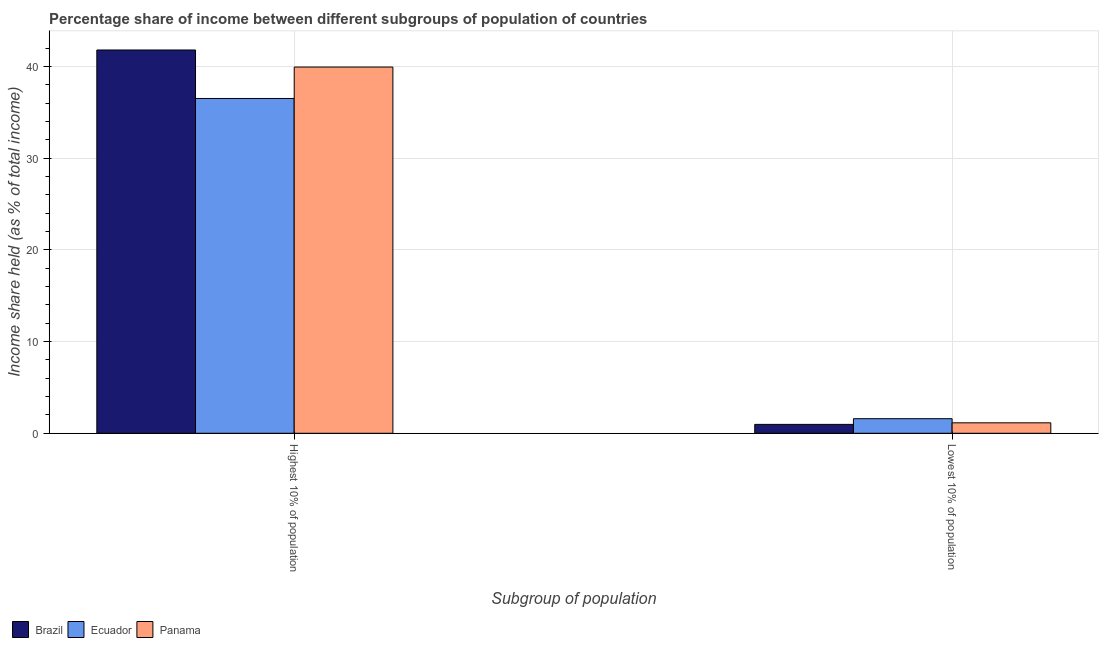How many different coloured bars are there?
Give a very brief answer. 3. How many groups of bars are there?
Your response must be concise. 2. What is the label of the 2nd group of bars from the left?
Your response must be concise. Lowest 10% of population. What is the income share held by highest 10% of the population in Ecuador?
Provide a short and direct response. 36.53. Across all countries, what is the maximum income share held by highest 10% of the population?
Offer a very short reply. 41.82. Across all countries, what is the minimum income share held by highest 10% of the population?
Offer a very short reply. 36.53. In which country was the income share held by highest 10% of the population maximum?
Offer a terse response. Brazil. In which country was the income share held by highest 10% of the population minimum?
Provide a short and direct response. Ecuador. What is the total income share held by highest 10% of the population in the graph?
Your response must be concise. 118.31. What is the difference between the income share held by highest 10% of the population in Brazil and that in Ecuador?
Provide a succinct answer. 5.29. What is the difference between the income share held by highest 10% of the population in Ecuador and the income share held by lowest 10% of the population in Panama?
Provide a succinct answer. 35.39. What is the average income share held by lowest 10% of the population per country?
Provide a short and direct response. 1.23. What is the difference between the income share held by lowest 10% of the population and income share held by highest 10% of the population in Panama?
Ensure brevity in your answer.  -38.82. In how many countries, is the income share held by highest 10% of the population greater than 40 %?
Provide a short and direct response. 1. What is the ratio of the income share held by lowest 10% of the population in Brazil to that in Ecuador?
Make the answer very short. 0.61. What does the 3rd bar from the left in Lowest 10% of population represents?
Provide a succinct answer. Panama. What does the 2nd bar from the right in Lowest 10% of population represents?
Your answer should be very brief. Ecuador. How many bars are there?
Keep it short and to the point. 6. Are all the bars in the graph horizontal?
Offer a terse response. No. How many countries are there in the graph?
Keep it short and to the point. 3. What is the difference between two consecutive major ticks on the Y-axis?
Provide a short and direct response. 10. Are the values on the major ticks of Y-axis written in scientific E-notation?
Make the answer very short. No. How many legend labels are there?
Your answer should be compact. 3. How are the legend labels stacked?
Give a very brief answer. Horizontal. What is the title of the graph?
Your answer should be compact. Percentage share of income between different subgroups of population of countries. What is the label or title of the X-axis?
Your answer should be compact. Subgroup of population. What is the label or title of the Y-axis?
Offer a terse response. Income share held (as % of total income). What is the Income share held (as % of total income) of Brazil in Highest 10% of population?
Make the answer very short. 41.82. What is the Income share held (as % of total income) in Ecuador in Highest 10% of population?
Provide a short and direct response. 36.53. What is the Income share held (as % of total income) of Panama in Highest 10% of population?
Provide a short and direct response. 39.96. What is the Income share held (as % of total income) of Ecuador in Lowest 10% of population?
Your answer should be very brief. 1.59. What is the Income share held (as % of total income) of Panama in Lowest 10% of population?
Keep it short and to the point. 1.14. Across all Subgroup of population, what is the maximum Income share held (as % of total income) in Brazil?
Offer a terse response. 41.82. Across all Subgroup of population, what is the maximum Income share held (as % of total income) of Ecuador?
Give a very brief answer. 36.53. Across all Subgroup of population, what is the maximum Income share held (as % of total income) in Panama?
Ensure brevity in your answer.  39.96. Across all Subgroup of population, what is the minimum Income share held (as % of total income) in Brazil?
Your response must be concise. 0.97. Across all Subgroup of population, what is the minimum Income share held (as % of total income) in Ecuador?
Ensure brevity in your answer.  1.59. Across all Subgroup of population, what is the minimum Income share held (as % of total income) in Panama?
Offer a terse response. 1.14. What is the total Income share held (as % of total income) in Brazil in the graph?
Provide a short and direct response. 42.79. What is the total Income share held (as % of total income) in Ecuador in the graph?
Your response must be concise. 38.12. What is the total Income share held (as % of total income) in Panama in the graph?
Your answer should be very brief. 41.1. What is the difference between the Income share held (as % of total income) of Brazil in Highest 10% of population and that in Lowest 10% of population?
Keep it short and to the point. 40.85. What is the difference between the Income share held (as % of total income) of Ecuador in Highest 10% of population and that in Lowest 10% of population?
Your response must be concise. 34.94. What is the difference between the Income share held (as % of total income) of Panama in Highest 10% of population and that in Lowest 10% of population?
Your response must be concise. 38.82. What is the difference between the Income share held (as % of total income) of Brazil in Highest 10% of population and the Income share held (as % of total income) of Ecuador in Lowest 10% of population?
Ensure brevity in your answer.  40.23. What is the difference between the Income share held (as % of total income) in Brazil in Highest 10% of population and the Income share held (as % of total income) in Panama in Lowest 10% of population?
Offer a very short reply. 40.68. What is the difference between the Income share held (as % of total income) in Ecuador in Highest 10% of population and the Income share held (as % of total income) in Panama in Lowest 10% of population?
Give a very brief answer. 35.39. What is the average Income share held (as % of total income) of Brazil per Subgroup of population?
Your answer should be very brief. 21.39. What is the average Income share held (as % of total income) of Ecuador per Subgroup of population?
Ensure brevity in your answer.  19.06. What is the average Income share held (as % of total income) of Panama per Subgroup of population?
Ensure brevity in your answer.  20.55. What is the difference between the Income share held (as % of total income) of Brazil and Income share held (as % of total income) of Ecuador in Highest 10% of population?
Give a very brief answer. 5.29. What is the difference between the Income share held (as % of total income) in Brazil and Income share held (as % of total income) in Panama in Highest 10% of population?
Provide a succinct answer. 1.86. What is the difference between the Income share held (as % of total income) in Ecuador and Income share held (as % of total income) in Panama in Highest 10% of population?
Provide a short and direct response. -3.43. What is the difference between the Income share held (as % of total income) of Brazil and Income share held (as % of total income) of Ecuador in Lowest 10% of population?
Make the answer very short. -0.62. What is the difference between the Income share held (as % of total income) in Brazil and Income share held (as % of total income) in Panama in Lowest 10% of population?
Your answer should be very brief. -0.17. What is the difference between the Income share held (as % of total income) in Ecuador and Income share held (as % of total income) in Panama in Lowest 10% of population?
Keep it short and to the point. 0.45. What is the ratio of the Income share held (as % of total income) of Brazil in Highest 10% of population to that in Lowest 10% of population?
Keep it short and to the point. 43.11. What is the ratio of the Income share held (as % of total income) of Ecuador in Highest 10% of population to that in Lowest 10% of population?
Provide a succinct answer. 22.97. What is the ratio of the Income share held (as % of total income) in Panama in Highest 10% of population to that in Lowest 10% of population?
Your answer should be very brief. 35.05. What is the difference between the highest and the second highest Income share held (as % of total income) in Brazil?
Provide a short and direct response. 40.85. What is the difference between the highest and the second highest Income share held (as % of total income) of Ecuador?
Ensure brevity in your answer.  34.94. What is the difference between the highest and the second highest Income share held (as % of total income) of Panama?
Offer a very short reply. 38.82. What is the difference between the highest and the lowest Income share held (as % of total income) in Brazil?
Ensure brevity in your answer.  40.85. What is the difference between the highest and the lowest Income share held (as % of total income) in Ecuador?
Provide a succinct answer. 34.94. What is the difference between the highest and the lowest Income share held (as % of total income) in Panama?
Your response must be concise. 38.82. 